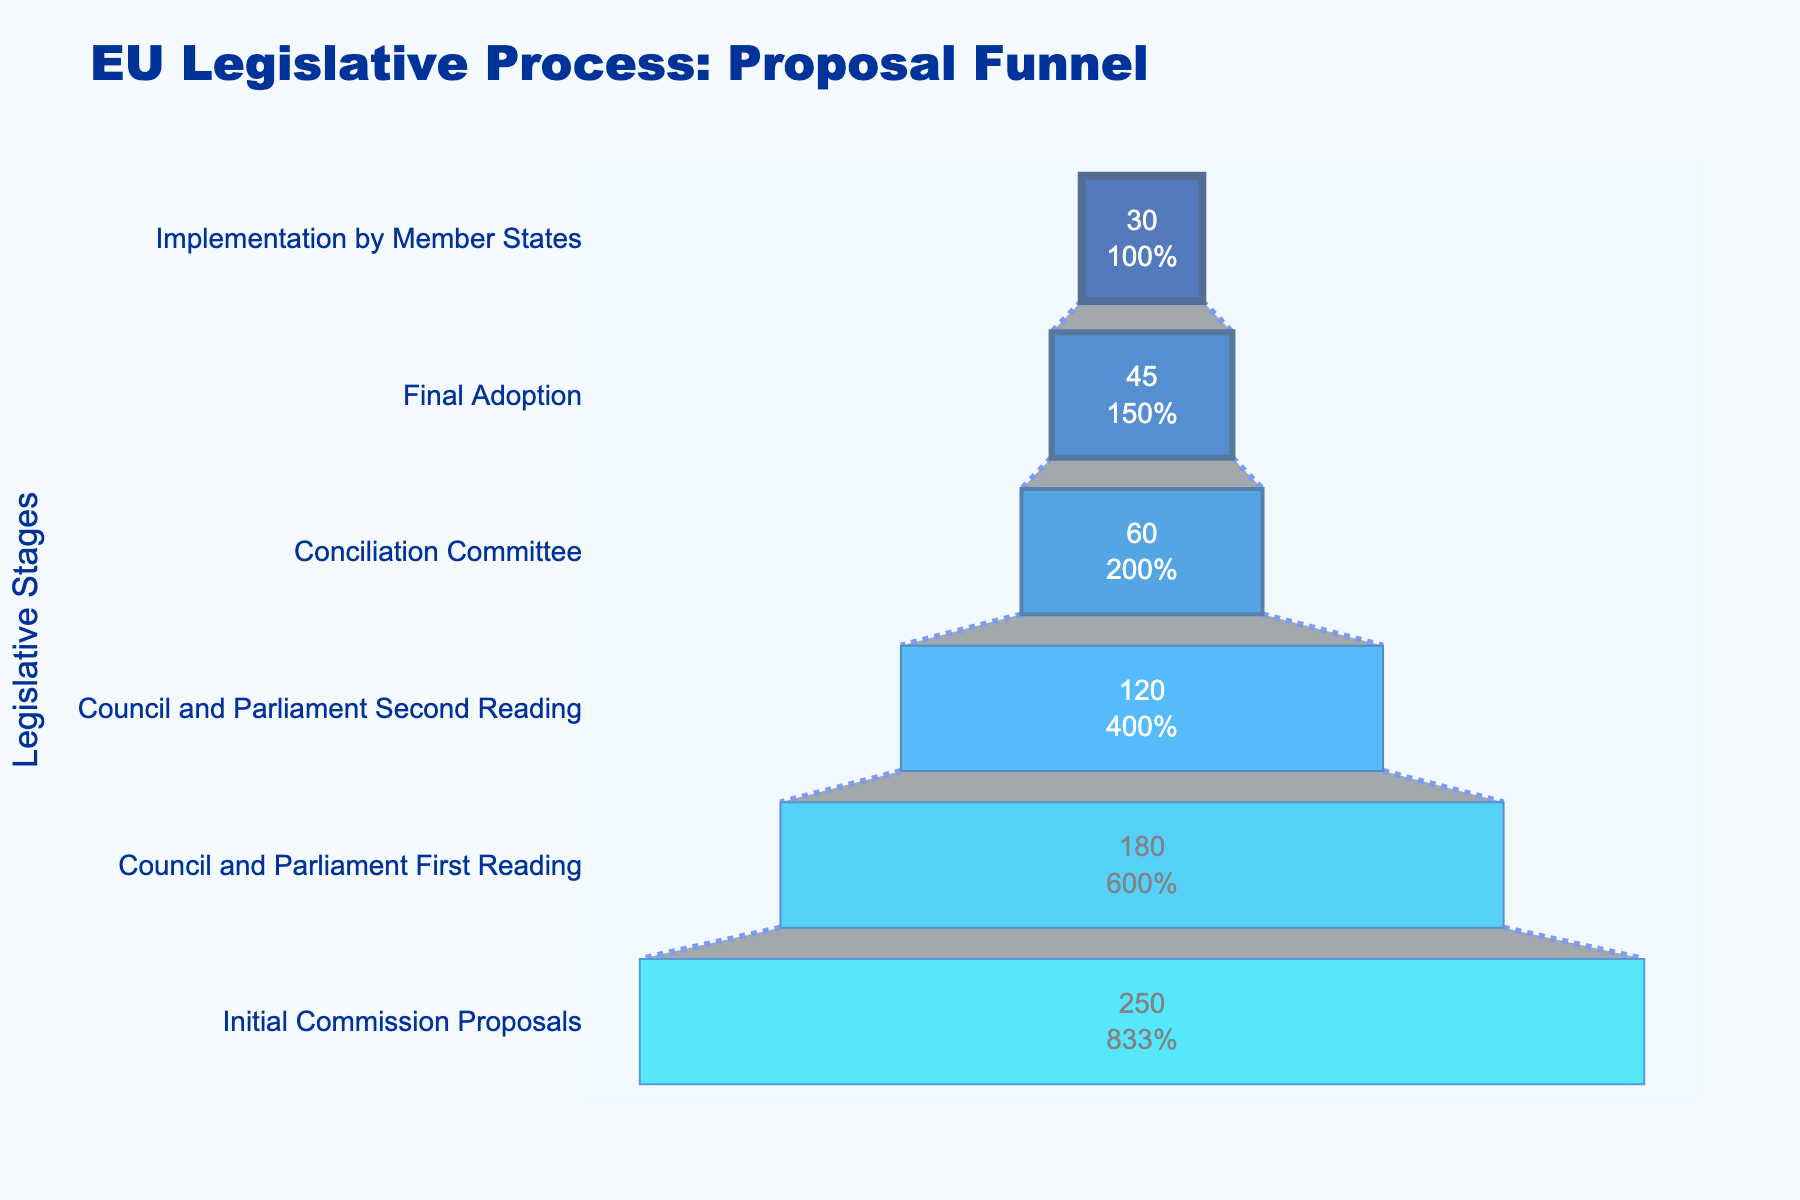What's the title of the figure? Look at the text at the top of the figure. It indicates the main subject of the figure.
Answer: EU Legislative Process: Proposal Funnel How many legislative stages are represented in the funnel chart? Count the distinct horizontal sections labeled with the stages of the legislative process.
Answer: 6 What is the number of proposals at the "Council and Parliament First Reading" stage? Identify the section labeled "Council and Parliament First Reading" and refer to the value inside that section.
Answer: 180 Which stage has the fewest number of proposals? Compare the values across all stages and identify the smallest one.
Answer: Implementation by Member States What is the difference in the number of proposals between the "Conciliation Committee" and "Final Adoption" stages? Subtract the number of proposals in the "Final Adoption" stage from the number in the "Conciliation Committee" stage: 60 - 45 = 15.
Answer: 15 By what percentage does the number of proposals reduce from the "Initial Commission Proposals" to the "Council and Parliament First Reading"? Calculate the percentage reduction: ((250 - 180) / 250) * 100 = 28%.
Answer: 28% At which stage does the number of proposals drop by exactly 50% from the previous stage? Check where the number of proposals in the current stage is half of the previous stage’s proposals: From "Council and Parliament Second Reading" (120) to "Conciliation Committee" (60).
Answer: Conciliation Committee What is the total number of proposals that reach the "Implementation by Member States" stage? Refer to the value inside the section labeled "Implementation by Member States".
Answer: 30 What's the percentage of proposals that reach the "Final Adoption" stage out of the initial proposals? Calculate the percentage: (45 / 250) * 100 = 18%.
Answer: 18% How many more proposals are there at the "Initial Commission Proposals" stage than at the "Final Adoption" stage? Subtract the number of proposals in the "Final Adoption" stage from the "Initial Commission Proposals" stage: 250 - 45 = 205.
Answer: 205 